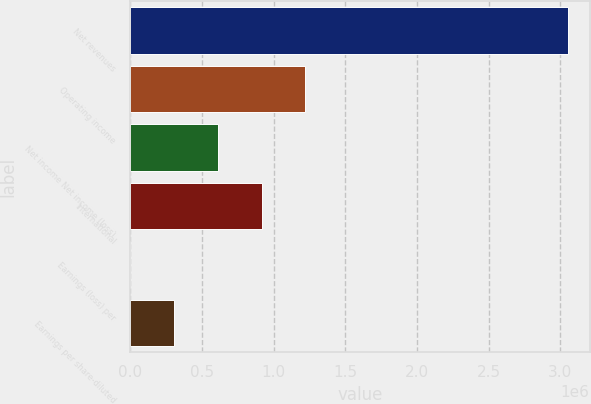Convert chart to OTSL. <chart><loc_0><loc_0><loc_500><loc_500><bar_chart><fcel>Net revenues<fcel>Operating income<fcel>Net income Net income (loss)<fcel>International<fcel>Earnings (loss) per<fcel>Earnings per share-diluted<nl><fcel>3.05286e+06<fcel>1.22114e+06<fcel>610572<fcel>915859<fcel>0.06<fcel>305286<nl></chart> 